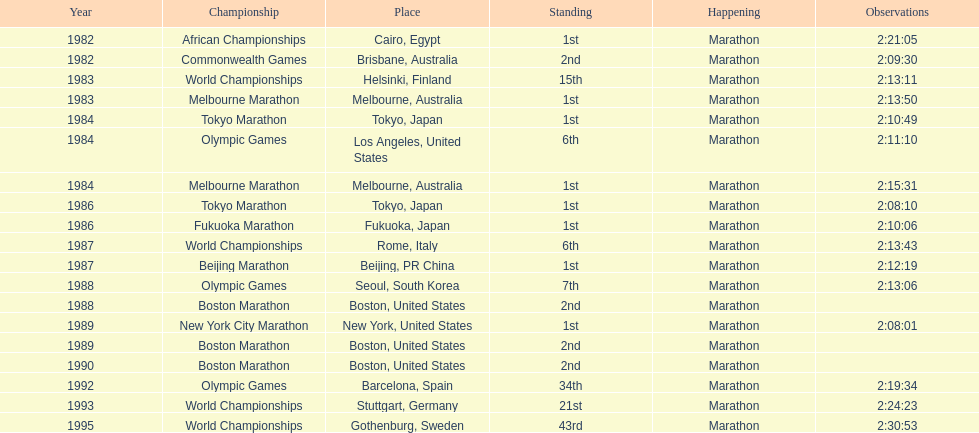Which competition is listed the most in this chart? World Championships. 